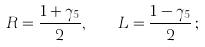Convert formula to latex. <formula><loc_0><loc_0><loc_500><loc_500>R = \frac { 1 + \gamma _ { 5 } } { 2 } , \quad L = \frac { 1 - \gamma _ { 5 } } { 2 } \, ;</formula> 